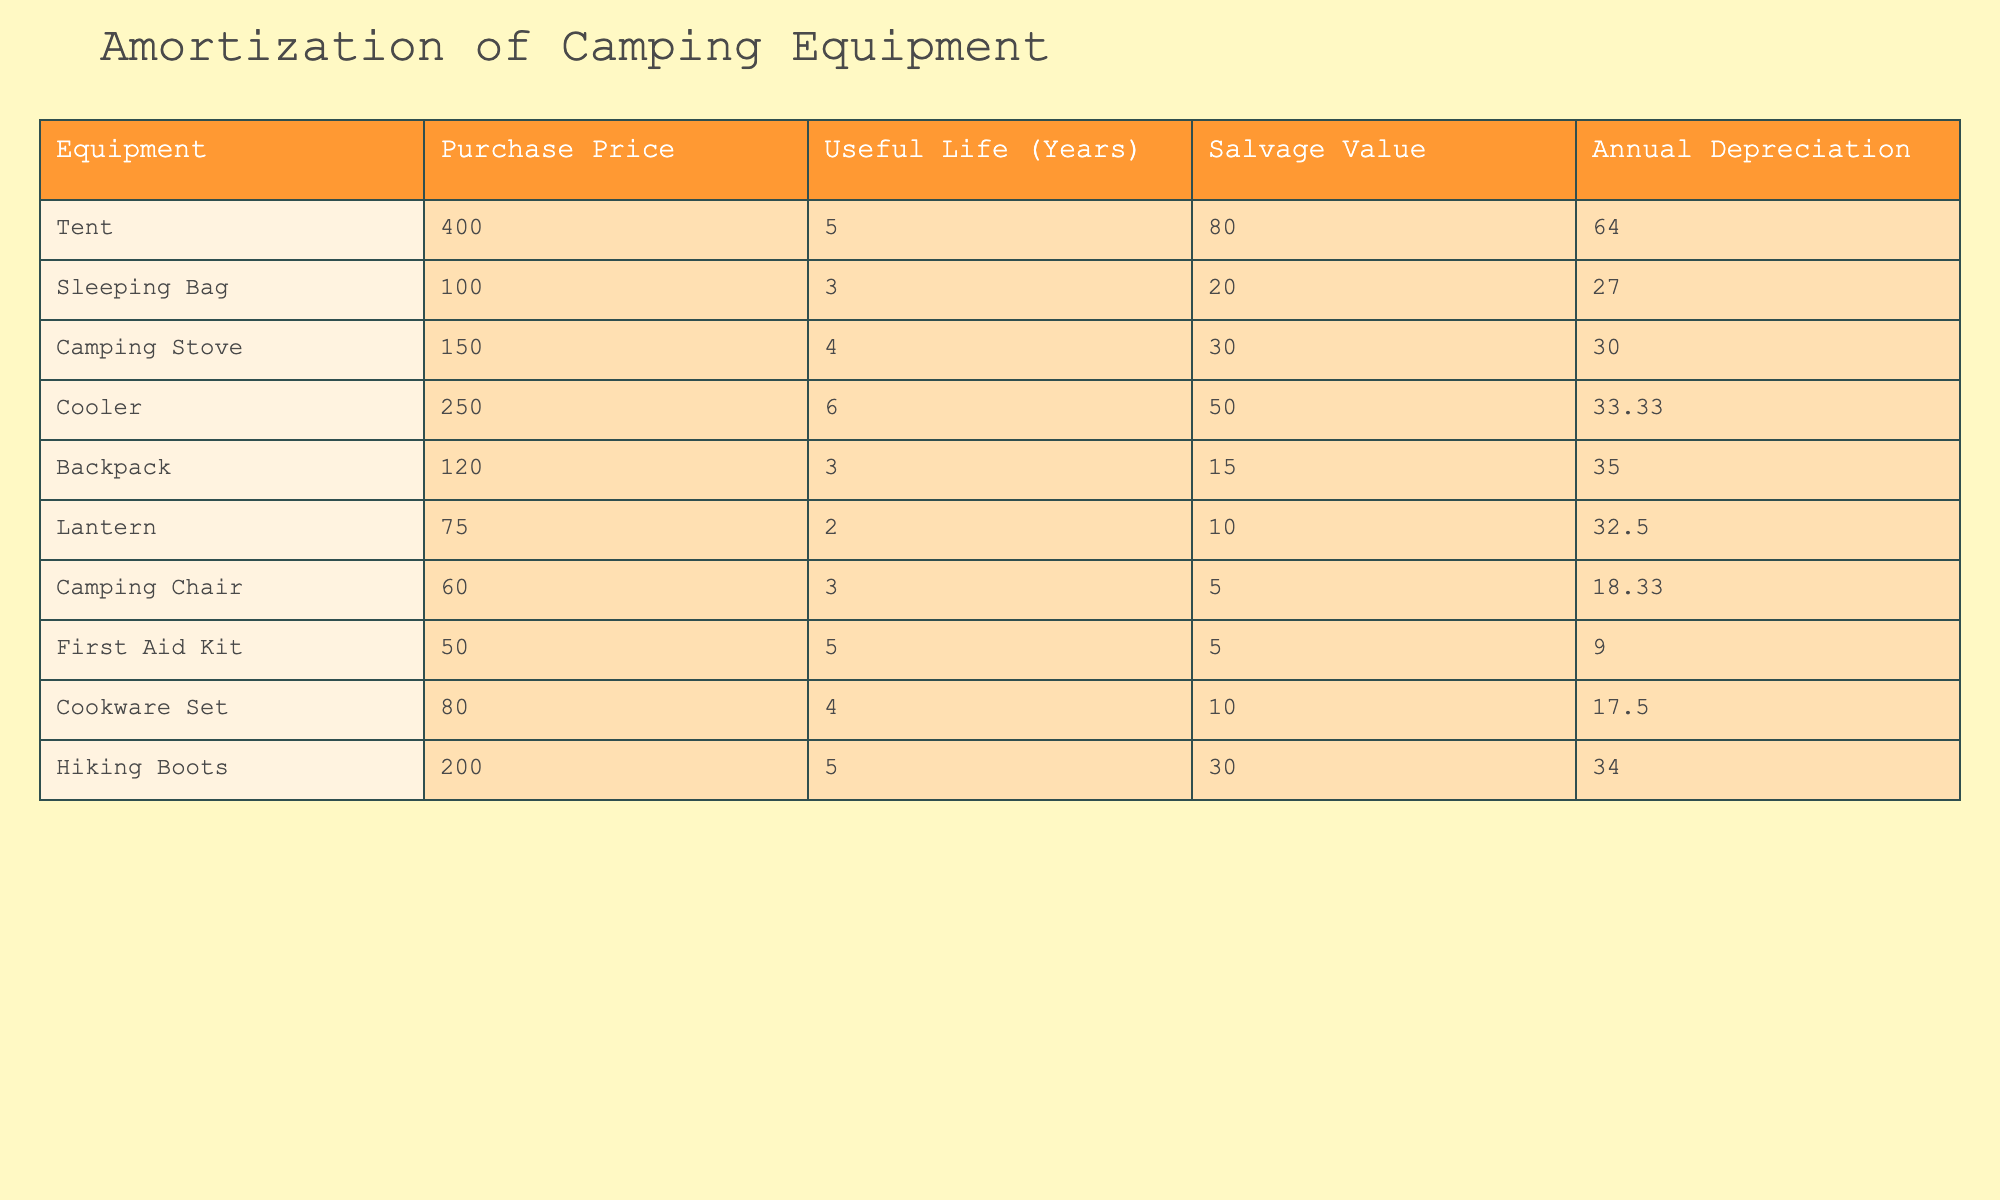What is the purchase price of the Camping Stove? The table shows each equipment item along with their respective purchase prices. Looking at the row for Camping Stove, the purchase price listed is 150.
Answer: 150 What is the annual depreciation for the Tent? In the table, the annual depreciation is specifically provided for each piece of equipment. For the Tent, the annual depreciation is noted as 64.
Answer: 64 Which equipment has the longest useful life? To find this, we need to look at the Useful Life column in the table. Among all items, the Cooler has the longest useful life at 6 years.
Answer: Cooler What is the total annual depreciation for all camping supplies listed? First, we sum the annual depreciation values for all items. This is calculated as: 64 + 27 + 30 + 33.33 + 35 + 32.5 + 18.33 + 9 + 17.5 + 34 =  305.16.
Answer: 305.16 Is the salvage value of the Sleeping Bag greater than its annual depreciation? The table lists the salvage value of the Sleeping Bag as 20 and its annual depreciation as 27. Since 20 is less than 27, the statement is false.
Answer: No How much does the Backpack depreciate per year compared to the Cooler? The Backpack has an annual depreciation of 35, while the Cooler’s annual depreciation is 33.33. Comparing these annual depreciations, the Backpack depreciates more per year by 35 - 33.33 = 1.67.
Answer: 1.67 Which equipment has a salvage value higher than its annual depreciation? We go through the table and find which equipment has a salvage value greater than the corresponding annual depreciation. The Tent, Cooler, and Hiking Boots all show higher salvage values (80, 50, and 30 respectively) than their annual depreciation (64, 33.33, 34).
Answer: Tent, Cooler, Hiking Boots What is the average useful life of all the equipment? First, we add up the useful life of all items: 5 + 3 + 4 + 6 + 3 + 2 + 3 + 5 + 4 + 5 = 43. Then, we divide by the number of items (10) to find the average: 43 / 10 = 4.3 years.
Answer: 4.3 years Was any equipment purchased for less than 100? After checking the Purchase Price column, we find that the Sleeping Bag (100) and Lantern (75) were purchased for less than 100. Thus, at least one item was purchased for less than 100.
Answer: Yes 